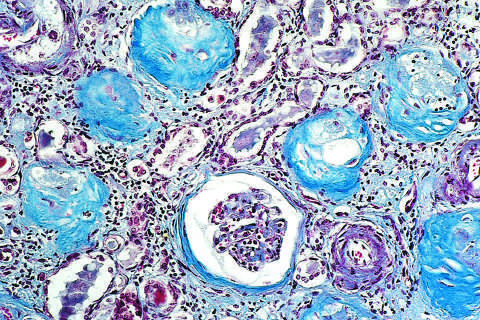what shows complete replacement of virtually all glomeruli by blue-staining collagen?
Answer the question using a single word or phrase. A masson trichrome preparation 